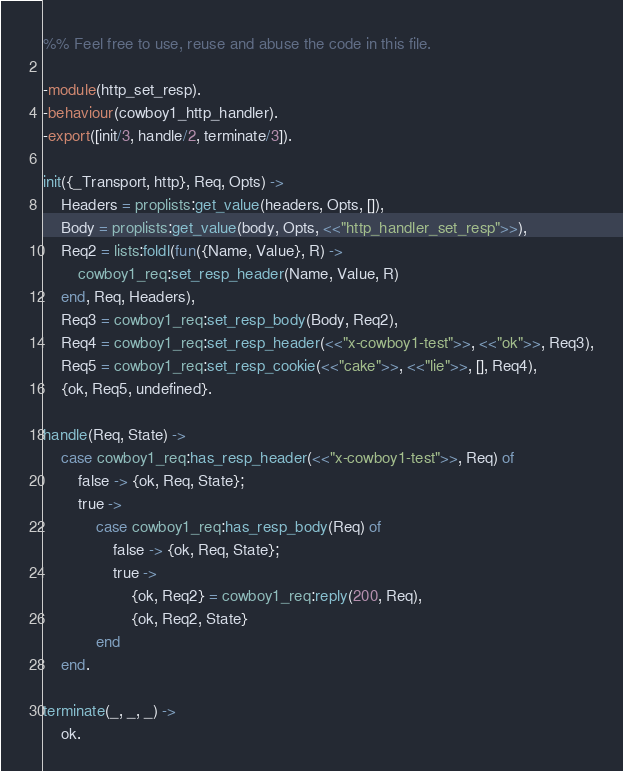Convert code to text. <code><loc_0><loc_0><loc_500><loc_500><_Erlang_>%% Feel free to use, reuse and abuse the code in this file.

-module(http_set_resp).
-behaviour(cowboy1_http_handler).
-export([init/3, handle/2, terminate/3]).

init({_Transport, http}, Req, Opts) ->
	Headers = proplists:get_value(headers, Opts, []),
	Body = proplists:get_value(body, Opts, <<"http_handler_set_resp">>),
	Req2 = lists:foldl(fun({Name, Value}, R) ->
		cowboy1_req:set_resp_header(Name, Value, R)
	end, Req, Headers),
	Req3 = cowboy1_req:set_resp_body(Body, Req2),
	Req4 = cowboy1_req:set_resp_header(<<"x-cowboy1-test">>, <<"ok">>, Req3),
	Req5 = cowboy1_req:set_resp_cookie(<<"cake">>, <<"lie">>, [], Req4),
	{ok, Req5, undefined}.

handle(Req, State) ->
	case cowboy1_req:has_resp_header(<<"x-cowboy1-test">>, Req) of
		false -> {ok, Req, State};
		true ->
			case cowboy1_req:has_resp_body(Req) of
				false -> {ok, Req, State};
				true ->
					{ok, Req2} = cowboy1_req:reply(200, Req),
					{ok, Req2, State}
			end
	end.

terminate(_, _, _) ->
	ok.
</code> 